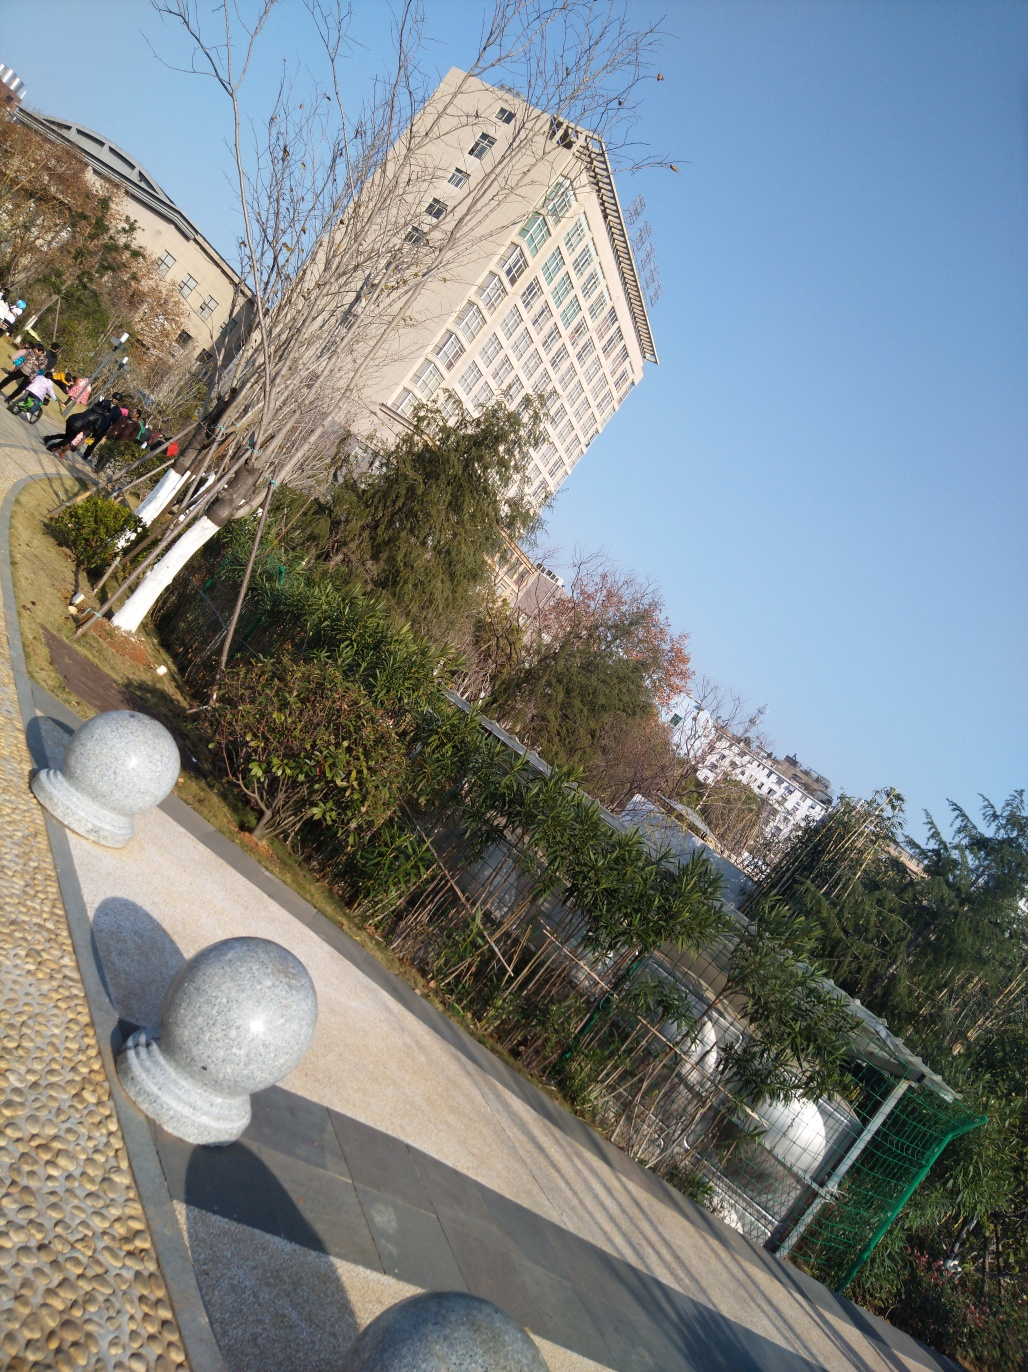Can you describe the environment shown in the image? The image displays a relatively open outdoor area. There's a leafless tree in the foreground, which might suggest it's either winter or the tree is dormant. In the background, there's a multi-story building with numerous windows, and beside it, we can see some bamboo and a structure that might be a greenhouse. The ground is made up of large, textured tiles, and there are spherical bollards along the walkway. The sky is clear, indicating a sunny day. 